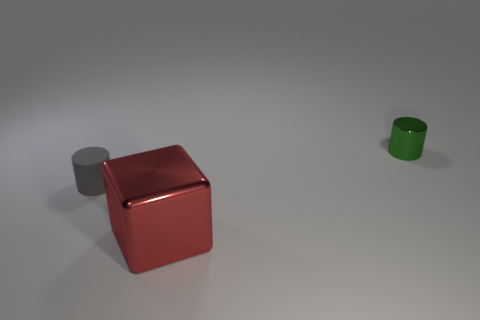Add 1 big shiny objects. How many objects exist? 4 Subtract all blocks. How many objects are left? 2 Add 2 tiny things. How many tiny things are left? 4 Add 3 large cyan blocks. How many large cyan blocks exist? 3 Subtract 1 green cylinders. How many objects are left? 2 Subtract all tiny brown matte cylinders. Subtract all large things. How many objects are left? 2 